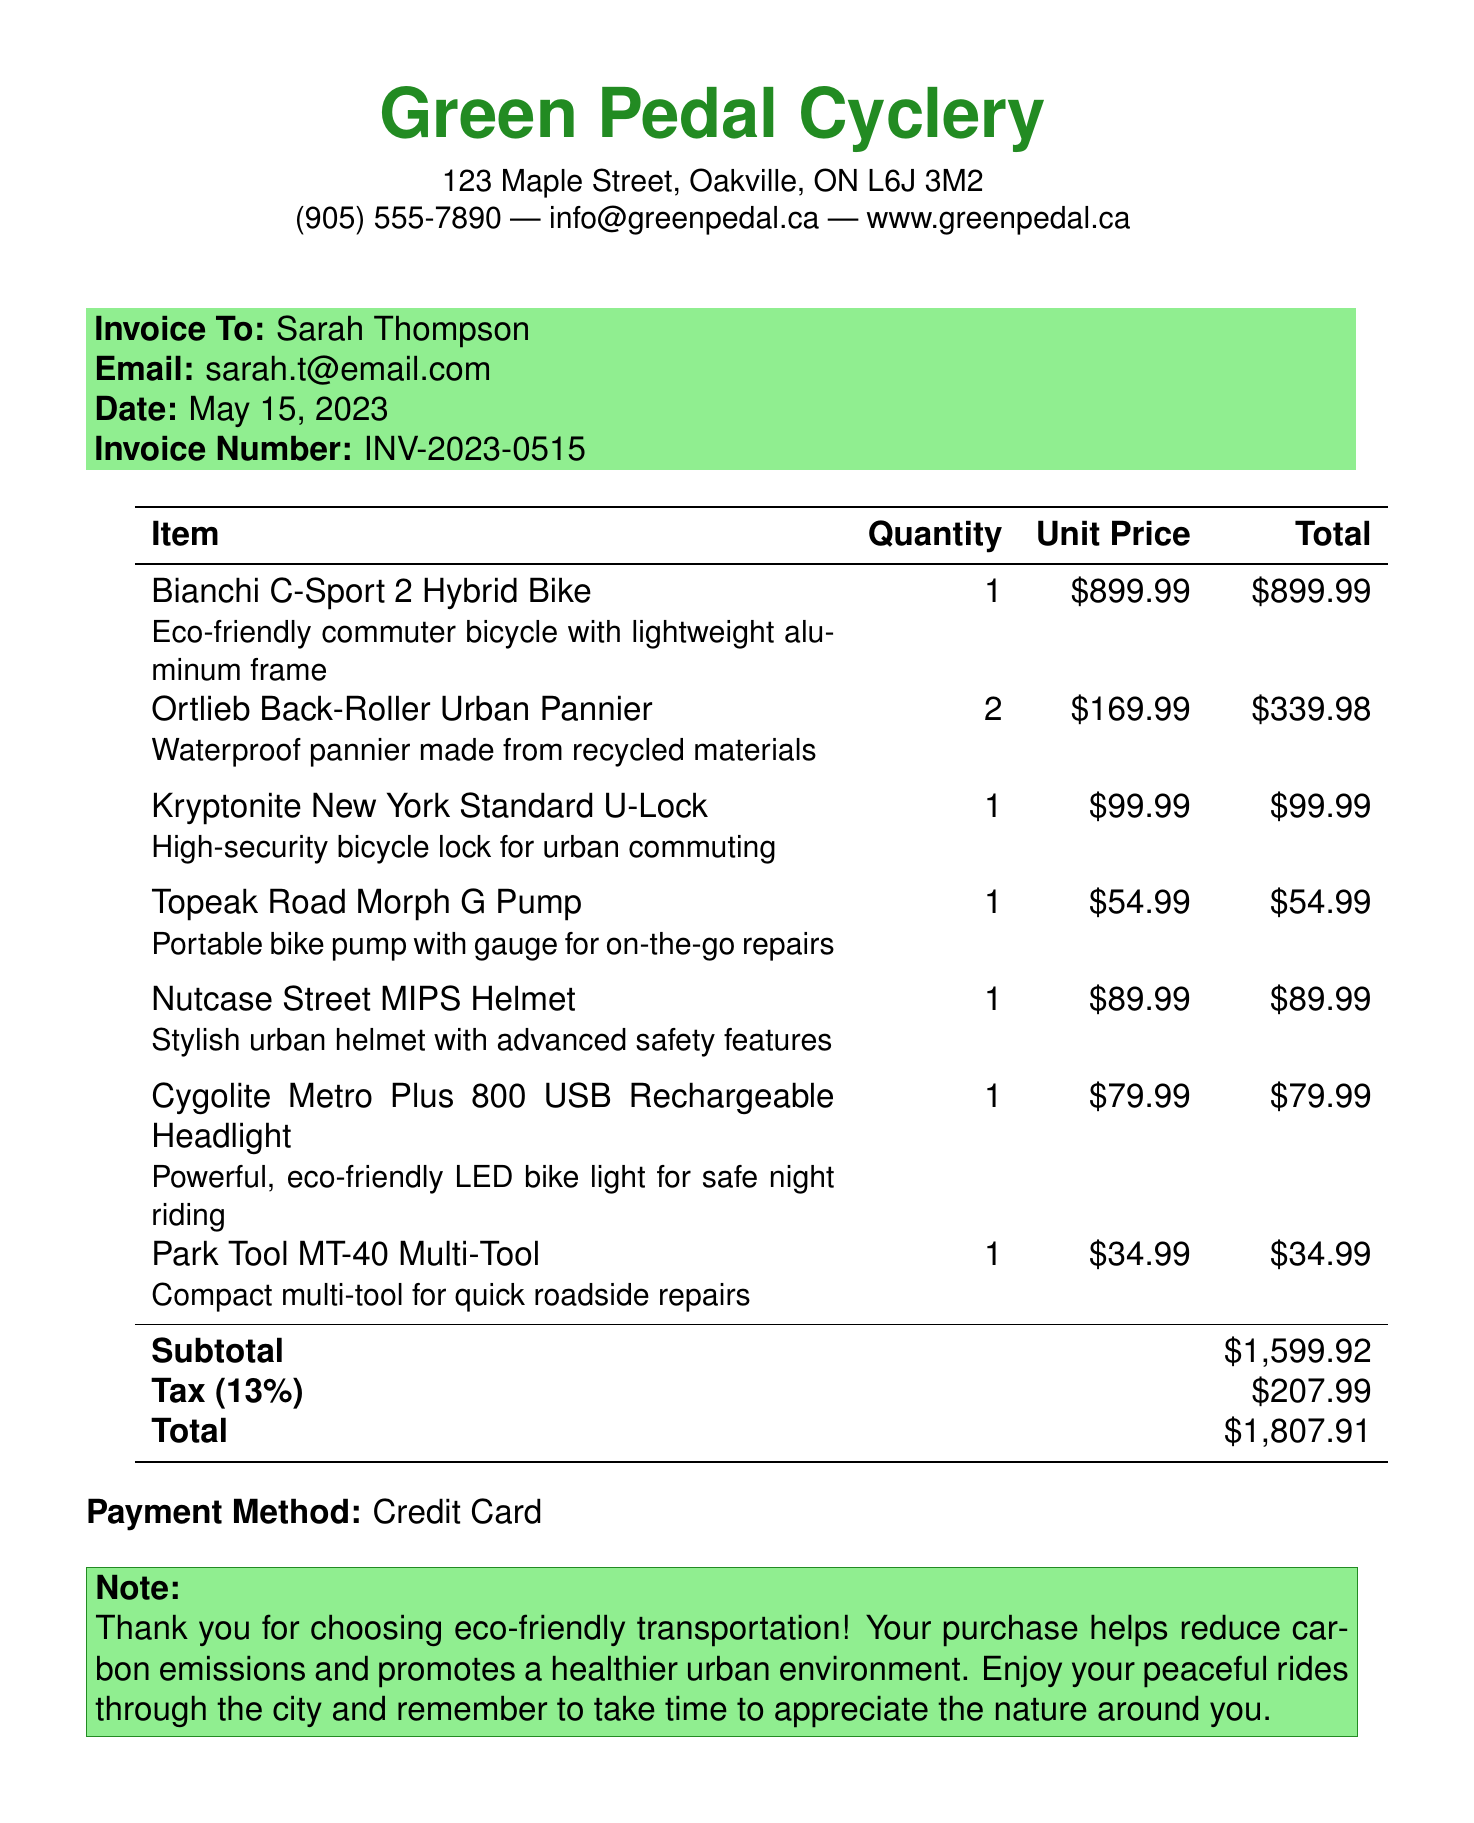what is the name of the shop? The shop's name is located at the beginning of the invoice document.
Answer: Green Pedal Cyclery what is the invoice number? The invoice number is specified in the header section of the document.
Answer: INV-2023-0515 who is the customer? The customer's name is found in the invoice details section.
Answer: Sarah Thompson what is the date of the invoice? The date is mentioned in the same section as the customer details.
Answer: May 15, 2023 how many Ortlieb Back-Roller Urban Panniers were purchased? The quantity of each item is listed in the itemized section of the invoice.
Answer: 2 what is the subtotal amount? The subtotal is displayed before tax in the financial summary of the document.
Answer: $1,599.92 what is the tax rate applied? The tax rate is explicitly mentioned in the invoice summary section.
Answer: 13% what is the total amount due? The total amount is the final figure shown in the financial summary of the document.
Answer: $1,807.91 what payment method was used? The payment method is indicated near the bottom of the invoice.
Answer: Credit Card what is the note provided to the customer? The note appears in a colored box towards the end of the document.
Answer: Thank you for choosing eco-friendly transportation! Your purchase helps reduce carbon emissions and promotes a healthier urban environment. Enjoy your peaceful rides through the city and remember to take time to appreciate the nature around you 